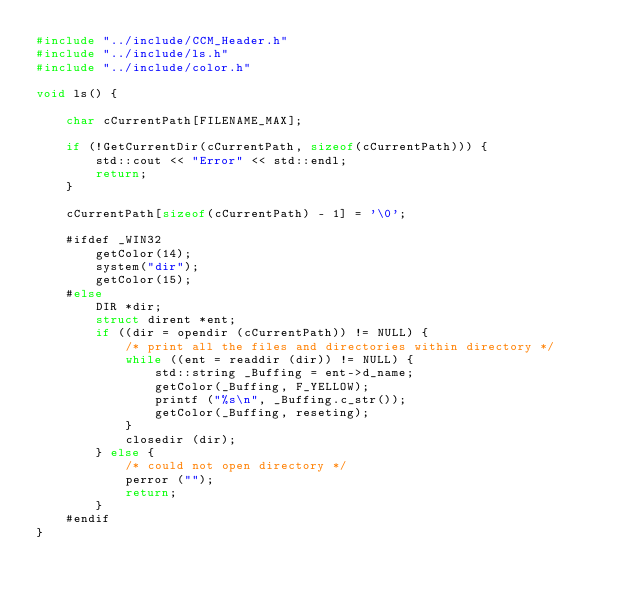<code> <loc_0><loc_0><loc_500><loc_500><_C++_>#include "../include/CCM_Header.h"
#include "../include/ls.h"
#include "../include/color.h"

void ls() {
    
    char cCurrentPath[FILENAME_MAX];

    if (!GetCurrentDir(cCurrentPath, sizeof(cCurrentPath))) {
        std::cout << "Error" << std::endl;
        return;
    }

    cCurrentPath[sizeof(cCurrentPath) - 1] = '\0';

    #ifdef _WIN32
        getColor(14);
        system("dir");
        getColor(15);
    #else
        DIR *dir;
        struct dirent *ent;
        if ((dir = opendir (cCurrentPath)) != NULL) {
            /* print all the files and directories within directory */
            while ((ent = readdir (dir)) != NULL) {
                std::string _Buffing = ent->d_name;
                getColor(_Buffing, F_YELLOW);
                printf ("%s\n", _Buffing.c_str());
                getColor(_Buffing, reseting);
            }
            closedir (dir);
        } else {
            /* could not open directory */
            perror ("");
            return;
        }
    #endif
}
</code> 